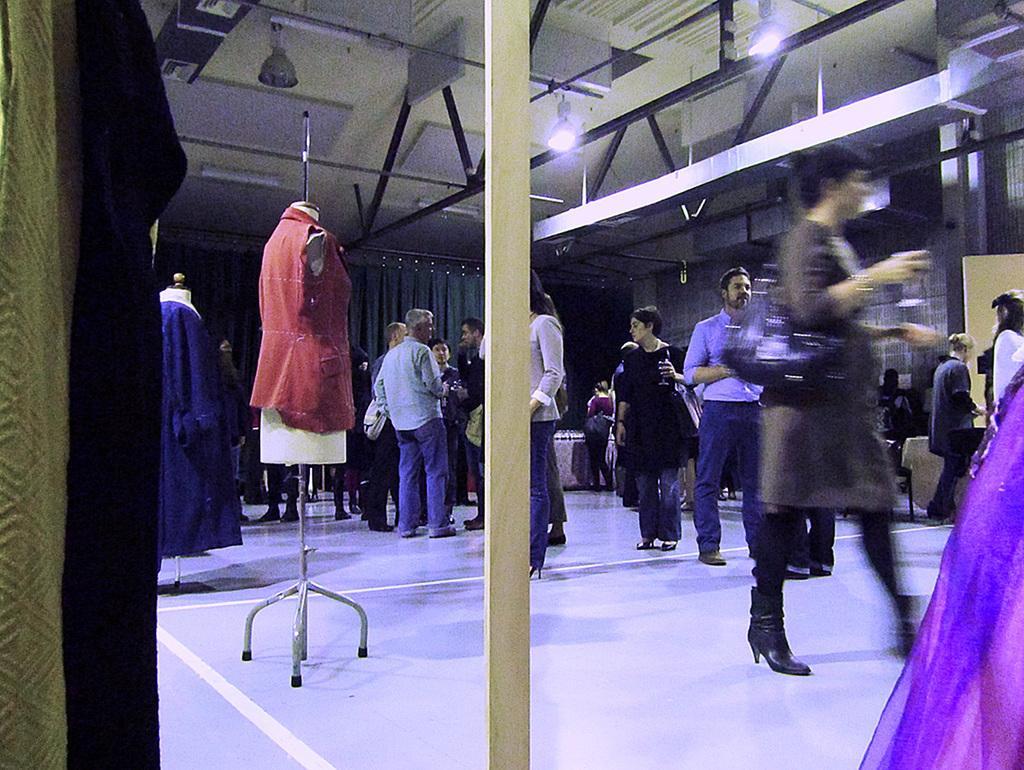Please provide a concise description of this image. There is a group of persons as we can see in the middle of this image. We can see roof at the top of this image and we can see mannequins on the left side of this image. 